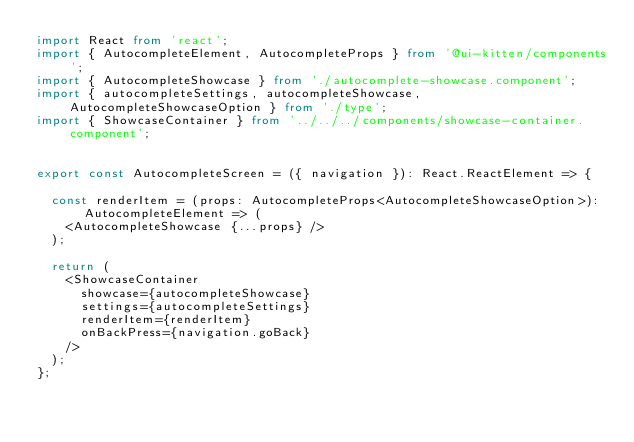Convert code to text. <code><loc_0><loc_0><loc_500><loc_500><_TypeScript_>import React from 'react';
import { AutocompleteElement, AutocompleteProps } from '@ui-kitten/components';
import { AutocompleteShowcase } from './autocomplete-showcase.component';
import { autocompleteSettings, autocompleteShowcase, AutocompleteShowcaseOption } from './type';
import { ShowcaseContainer } from '../../../components/showcase-container.component';


export const AutocompleteScreen = ({ navigation }): React.ReactElement => {

  const renderItem = (props: AutocompleteProps<AutocompleteShowcaseOption>): AutocompleteElement => (
    <AutocompleteShowcase {...props} />
  );

  return (
    <ShowcaseContainer
      showcase={autocompleteShowcase}
      settings={autocompleteSettings}
      renderItem={renderItem}
      onBackPress={navigation.goBack}
    />
  );
};
</code> 